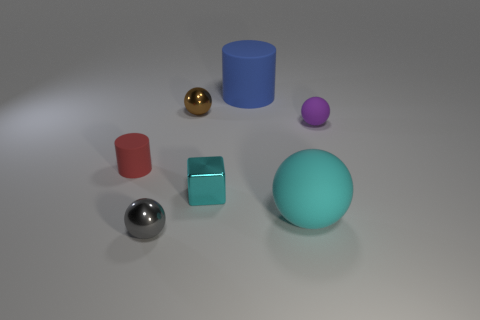Subtract all small brown balls. How many balls are left? 3 Add 3 brown balls. How many objects exist? 10 Subtract all cyan balls. How many balls are left? 3 Subtract all spheres. How many objects are left? 3 Subtract all blue spheres. Subtract all blue blocks. How many spheres are left? 4 Subtract all rubber things. Subtract all big red rubber spheres. How many objects are left? 3 Add 1 tiny gray balls. How many tiny gray balls are left? 2 Add 3 purple balls. How many purple balls exist? 4 Subtract 0 brown cylinders. How many objects are left? 7 